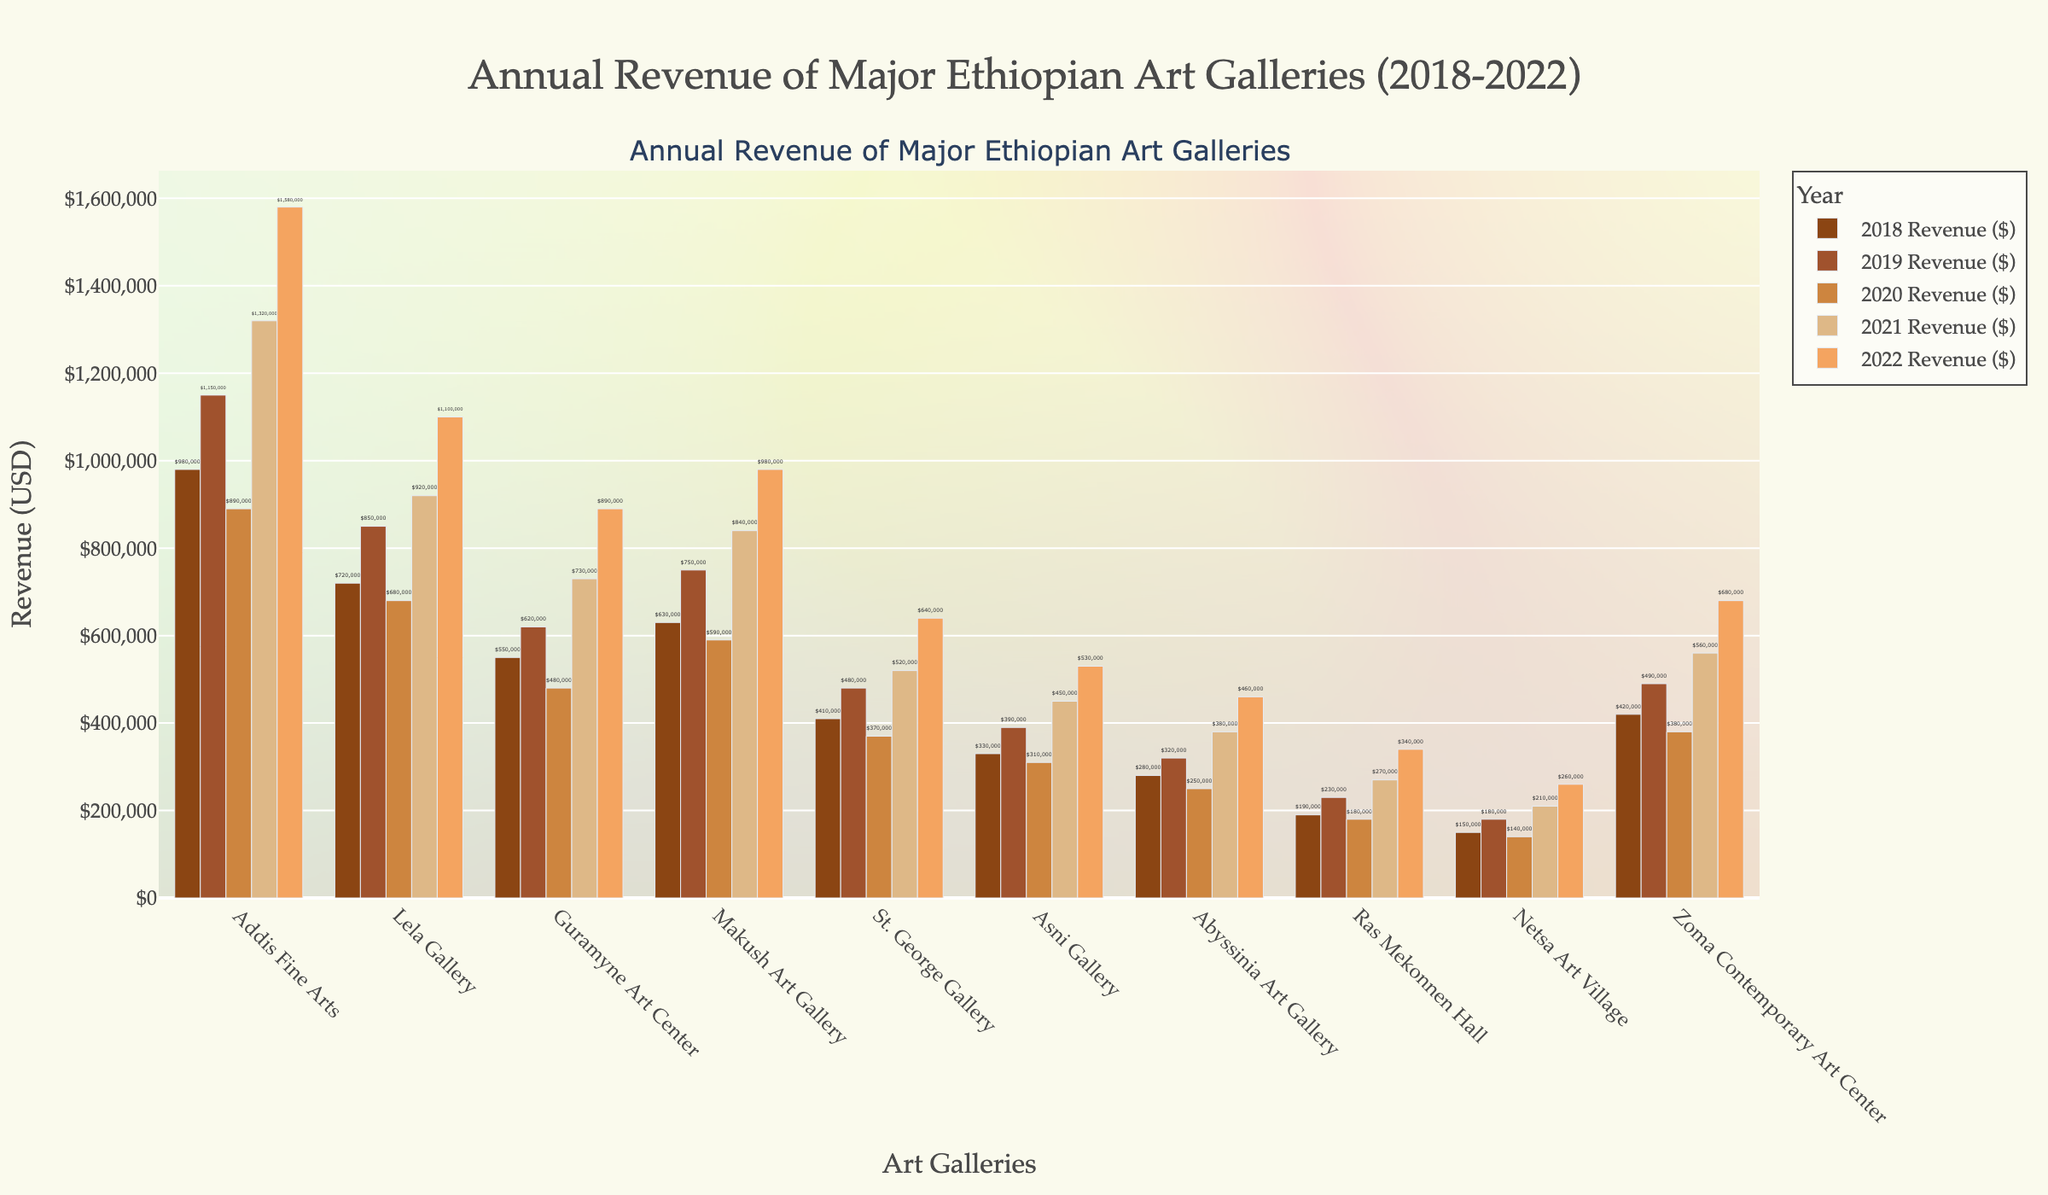what is the total revenue for Addis Fine Arts over the 5 years? To calculate the total revenue for Addis Fine Arts, sum up the revenue values from each year: 980,000 (2018) + 1,150,000 (2019) + 890,000 (2020) + 1,320,000 (2021) + 1,580,000 (2022) = 5,920,000
Answer: 5,920,000 which gallery had the highest revenue in 2022? Look at the bar heights or values for the year 2022; Addis Fine Arts has the highest revenue of 1,580,000 in 2022
Answer: Addis Fine Arts how did the revenue of Lela Gallery change from 2018 to 2022? Compare the revenue for Lela Gallery in 2018 (720,000) and 2022 (1,100,000). The difference is 1,100,000 - 720,000 = 380,000
Answer: Increased by 380,000 which two galleries had the closest revenue in 2020, and what is their revenue difference? Look at the bar heights or values for 2020 to find the closest two values. Asni Gallery (310,000) and Abyssinia Art Gallery (250,000) are the closest. The difference is 310,000 - 250,000 = 60,000
Answer: Asni Gallery and Abyssinia Art Gallery, 60,000 which year did Guramyne Art Center experience the largest increase in revenue, and by how much? Compare the revenue of Guramyne Art Center year over year. The largest increase occurs from 2020 (480,000) to 2021 (730,000), which is an increase of 730,000 - 480,000 = 250,000
Answer: 2021, 250,000 compare the average revenue of the three lowest-revenue galleries in 2019 Identify the three lowest-revenue galleries in 2019: Ras Mekonnen Hall (230,000), Netsa Art Village (180,000), Abyssinia Art Gallery (320,000). Calculate the average: (230,000 + 180,000 + 320,000) / 3 = 243,333.33
Answer: 243,333.33 in which year did most galleries experience a drop in revenue compared to the previous year? Review the year-over-year changes for each gallery and find the year when the majority had a decrease. In 2020, many galleries show a revenue drop compared to 2019
Answer: 2020 which gallery had the most consistent revenue over the 5 years? Examine the revenue values for consistency over the five years for all galleries. Makush Art Gallery appears to have the most consistent revenue with less fluctuation: 630,000, 750,000, 590,000, 840,000, 980,000
Answer: Makush Art Gallery how many galleries had a revenue of over 1 million dollars in 2021? Check the revenue values for 2021 and count the galleries with revenue over 1,000,000: Addis Fine Arts (1,320,000) and Lela Gallery (920,000 did not qualify). Only Addis Fine Arts qualifies
Answer: 1 what is the overall growth rate of Zoma Contemporary Art Center from 2018 to 2022? Calculate the growth rate using the formula: (final value - initial value) / initial value * 100%. For Zoma Contemporary Art Center: (680,000 - 420,000) / 420,000 * 100% = 61.90%
Answer: 61.90% 